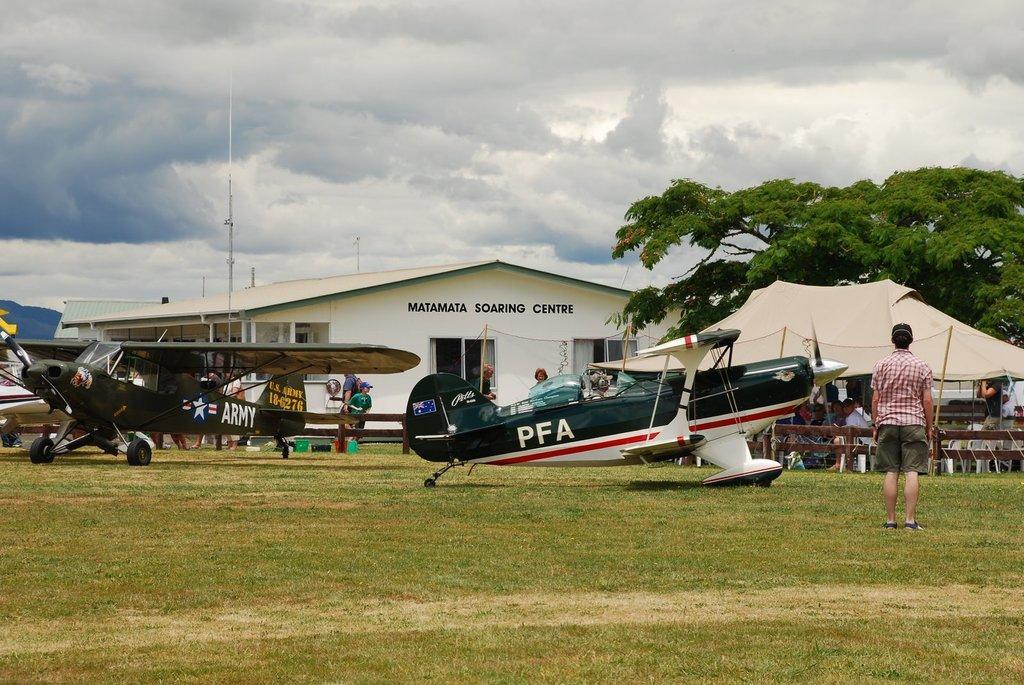How would you summarize this image in a sentence or two? In this picture we can see there are aircrafts on the grass and on the right side of the aircraft's a person is standing. Behind the aircraft's there is the wooden fence, a pole, a house, some people are standing and some people are sitting in the stall. Behind the stall there are trees and the sky. 